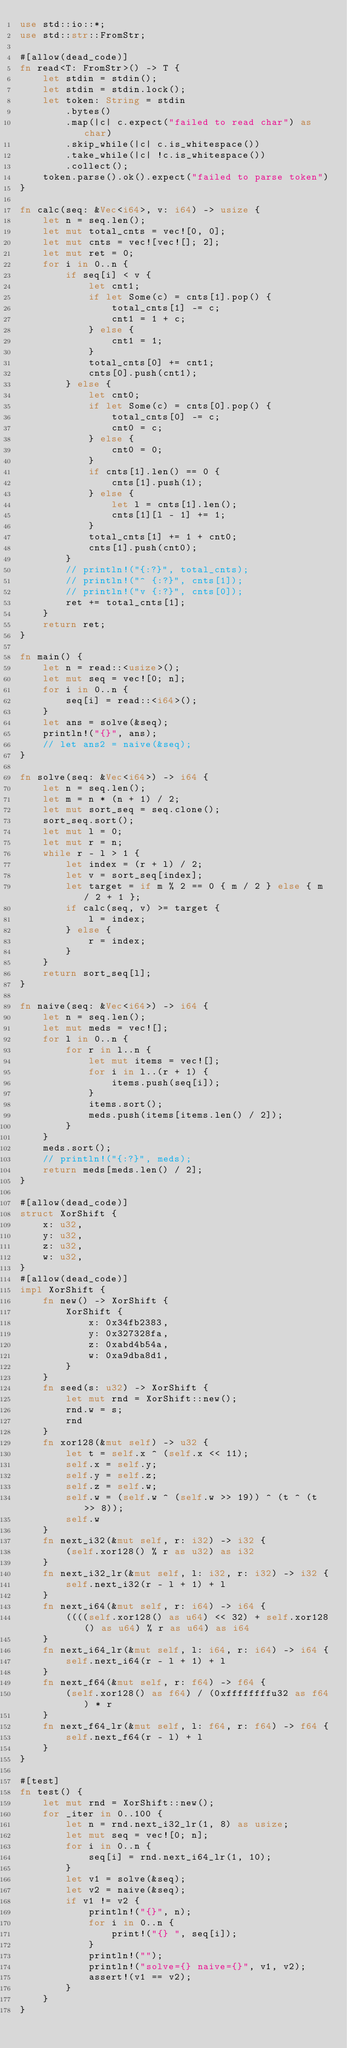Convert code to text. <code><loc_0><loc_0><loc_500><loc_500><_Rust_>use std::io::*;
use std::str::FromStr;

#[allow(dead_code)]
fn read<T: FromStr>() -> T {
    let stdin = stdin();
    let stdin = stdin.lock();
    let token: String = stdin
        .bytes()
        .map(|c| c.expect("failed to read char") as char)
        .skip_while(|c| c.is_whitespace())
        .take_while(|c| !c.is_whitespace())
        .collect();
    token.parse().ok().expect("failed to parse token")
}

fn calc(seq: &Vec<i64>, v: i64) -> usize {
    let n = seq.len();
    let mut total_cnts = vec![0, 0];
    let mut cnts = vec![vec![]; 2];
    let mut ret = 0;
    for i in 0..n {
        if seq[i] < v {
            let cnt1;
            if let Some(c) = cnts[1].pop() {
                total_cnts[1] -= c;
                cnt1 = 1 + c;
            } else {
                cnt1 = 1;
            }
            total_cnts[0] += cnt1;
            cnts[0].push(cnt1);
        } else {
            let cnt0;
            if let Some(c) = cnts[0].pop() {
                total_cnts[0] -= c;
                cnt0 = c;
            } else {
                cnt0 = 0;
            }
            if cnts[1].len() == 0 {
                cnts[1].push(1);
            } else {
                let l = cnts[1].len();
                cnts[1][l - 1] += 1;
            }
            total_cnts[1] += 1 + cnt0;
            cnts[1].push(cnt0);
        }
        // println!("{:?}", total_cnts);
        // println!("^ {:?}", cnts[1]);
        // println!("v {:?}", cnts[0]);
        ret += total_cnts[1];
    }
    return ret;
}

fn main() {
    let n = read::<usize>();
    let mut seq = vec![0; n];
    for i in 0..n {
        seq[i] = read::<i64>();
    }
    let ans = solve(&seq);
    println!("{}", ans);
    // let ans2 = naive(&seq);
}

fn solve(seq: &Vec<i64>) -> i64 {
    let n = seq.len();
    let m = n * (n + 1) / 2;
    let mut sort_seq = seq.clone();
    sort_seq.sort();
    let mut l = 0;
    let mut r = n;
    while r - l > 1 {
        let index = (r + l) / 2;
        let v = sort_seq[index];
        let target = if m % 2 == 0 { m / 2 } else { m / 2 + 1 };
        if calc(seq, v) >= target {
            l = index;
        } else {
            r = index;
        }
    }
    return sort_seq[l];
}

fn naive(seq: &Vec<i64>) -> i64 {
    let n = seq.len();
    let mut meds = vec![];
    for l in 0..n {
        for r in l..n {
            let mut items = vec![];
            for i in l..(r + 1) {
                items.push(seq[i]);
            }
            items.sort();
            meds.push(items[items.len() / 2]);
        }
    }
    meds.sort();
    // println!("{:?}", meds);
    return meds[meds.len() / 2];
}

#[allow(dead_code)]
struct XorShift {
    x: u32,
    y: u32,
    z: u32,
    w: u32,
}
#[allow(dead_code)]
impl XorShift {
    fn new() -> XorShift {
        XorShift {
            x: 0x34fb2383,
            y: 0x327328fa,
            z: 0xabd4b54a,
            w: 0xa9dba8d1,
        }
    }
    fn seed(s: u32) -> XorShift {
        let mut rnd = XorShift::new();
        rnd.w = s;
        rnd
    }
    fn xor128(&mut self) -> u32 {
        let t = self.x ^ (self.x << 11);
        self.x = self.y;
        self.y = self.z;
        self.z = self.w;
        self.w = (self.w ^ (self.w >> 19)) ^ (t ^ (t >> 8));
        self.w
    }
    fn next_i32(&mut self, r: i32) -> i32 {
        (self.xor128() % r as u32) as i32
    }
    fn next_i32_lr(&mut self, l: i32, r: i32) -> i32 {
        self.next_i32(r - l + 1) + l
    }
    fn next_i64(&mut self, r: i64) -> i64 {
        ((((self.xor128() as u64) << 32) + self.xor128() as u64) % r as u64) as i64
    }
    fn next_i64_lr(&mut self, l: i64, r: i64) -> i64 {
        self.next_i64(r - l + 1) + l
    }
    fn next_f64(&mut self, r: f64) -> f64 {
        (self.xor128() as f64) / (0xffffffffu32 as f64) * r
    }
    fn next_f64_lr(&mut self, l: f64, r: f64) -> f64 {
        self.next_f64(r - l) + l
    }
}

#[test]
fn test() {
    let mut rnd = XorShift::new();
    for _iter in 0..100 {
        let n = rnd.next_i32_lr(1, 8) as usize;
        let mut seq = vec![0; n];
        for i in 0..n {
            seq[i] = rnd.next_i64_lr(1, 10);
        }
        let v1 = solve(&seq);
        let v2 = naive(&seq);
        if v1 != v2 {
            println!("{}", n);
            for i in 0..n {
                print!("{} ", seq[i]);
            }
            println!("");
            println!("solve={} naive={}", v1, v2);
            assert!(v1 == v2);
        }
    }
}
</code> 